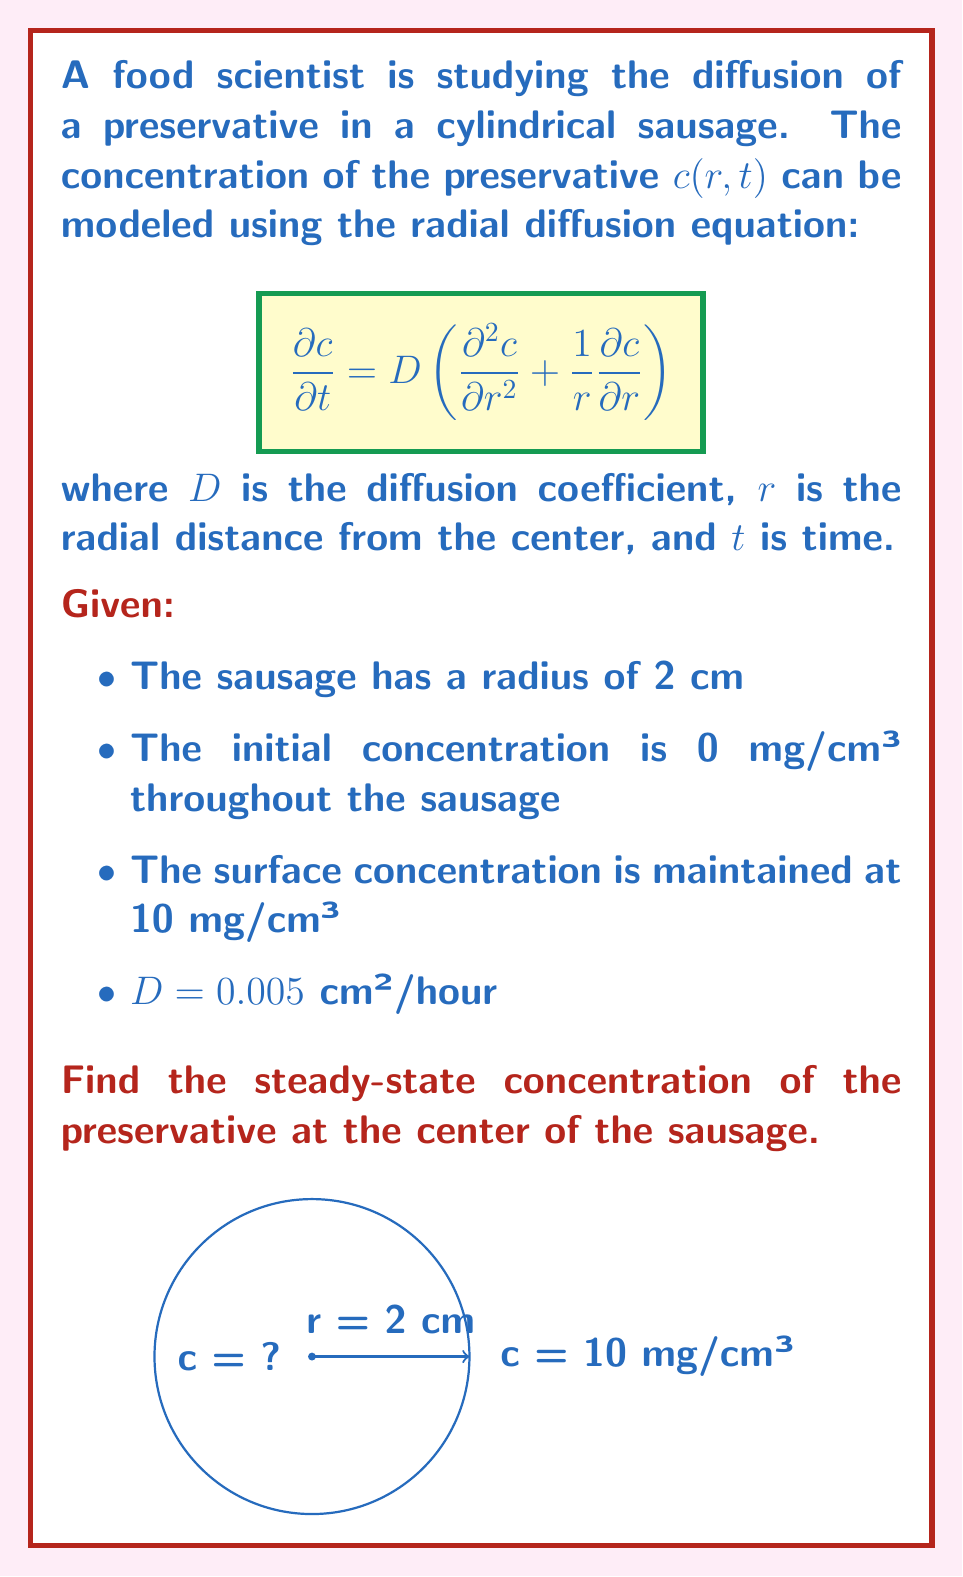Can you answer this question? To solve this problem, we follow these steps:

1) For steady-state conditions, $\frac{\partial c}{\partial t} = 0$. The diffusion equation reduces to:

   $$0 = D\left(\frac{d^2 c}{dr^2} + \frac{1}{r}\frac{dc}{dr}\right)$$

2) This can be rewritten as:

   $$\frac{d^2 c}{dr^2} + \frac{1}{r}\frac{dc}{dr} = 0$$

3) The general solution to this equation is:

   $$c(r) = A \ln(r) + B$$

   where $A$ and $B$ are constants to be determined from the boundary conditions.

4) Boundary conditions:
   - At $r = 2$ cm, $c = 10$ mg/cm³
   - At $r = 0$, $c$ must be finite

5) The second condition requires $A = 0$, otherwise $c$ would be undefined at $r = 0$.

6) Using the first condition:

   $$10 = B$$

7) Therefore, the steady-state solution is:

   $$c(r) = 10$$ mg/cm³

8) This constant solution means that at steady-state, the concentration is uniform throughout the sausage and equal to the surface concentration.

Thus, at the center of the sausage ($r = 0$), the steady-state concentration is 10 mg/cm³.
Answer: 10 mg/cm³ 